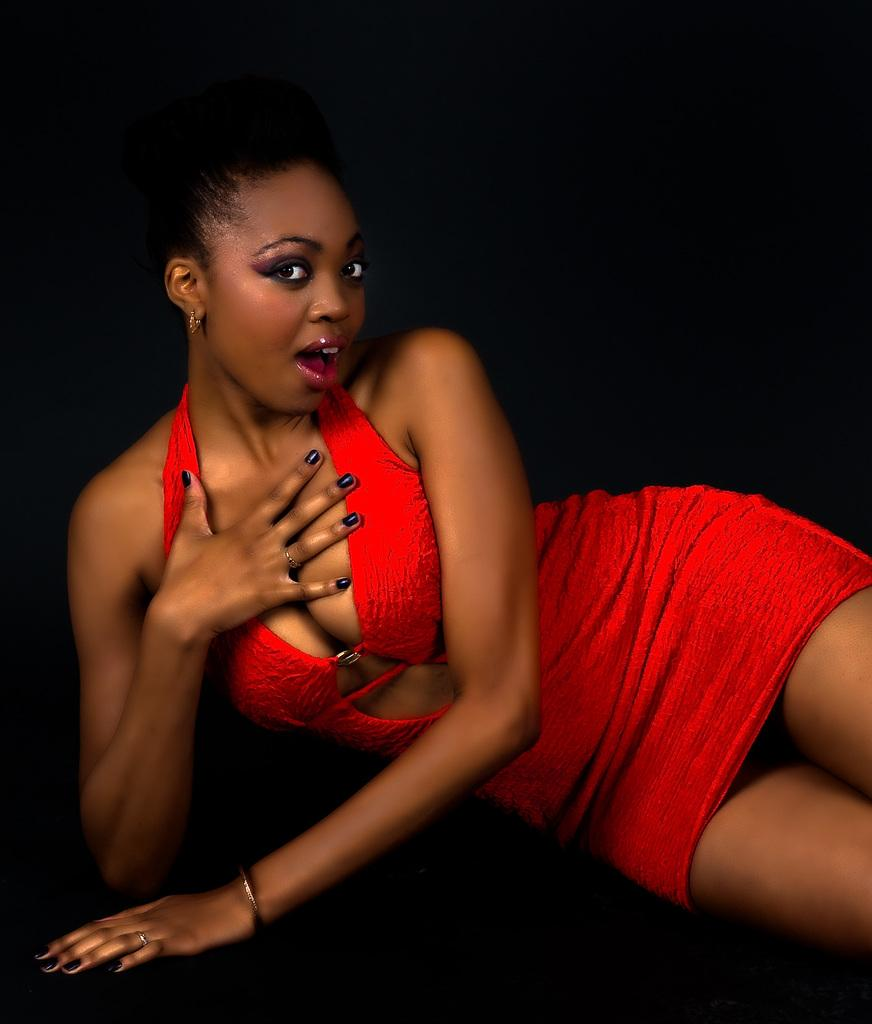Who is the main subject in the image? There is a woman in the image. What is the woman wearing? The woman is wearing a red dress. What is the woman's position in the image? The woman is laying on a path. What is the color of the background in the image? The background of the image is black. What is the actor's view of the coast in the image? There is no actor or coast present in the image; it features a woman laying on a path with a black background. 